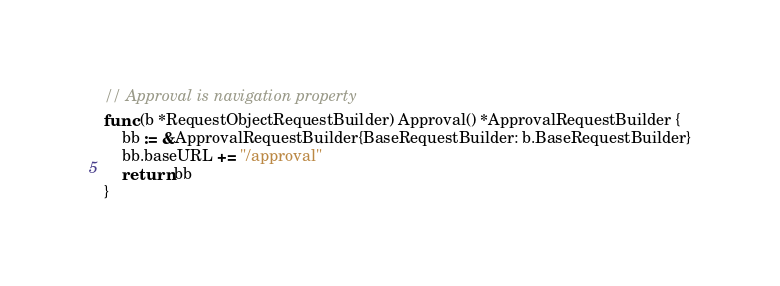Convert code to text. <code><loc_0><loc_0><loc_500><loc_500><_Go_>
// Approval is navigation property
func (b *RequestObjectRequestBuilder) Approval() *ApprovalRequestBuilder {
	bb := &ApprovalRequestBuilder{BaseRequestBuilder: b.BaseRequestBuilder}
	bb.baseURL += "/approval"
	return bb
}
</code> 